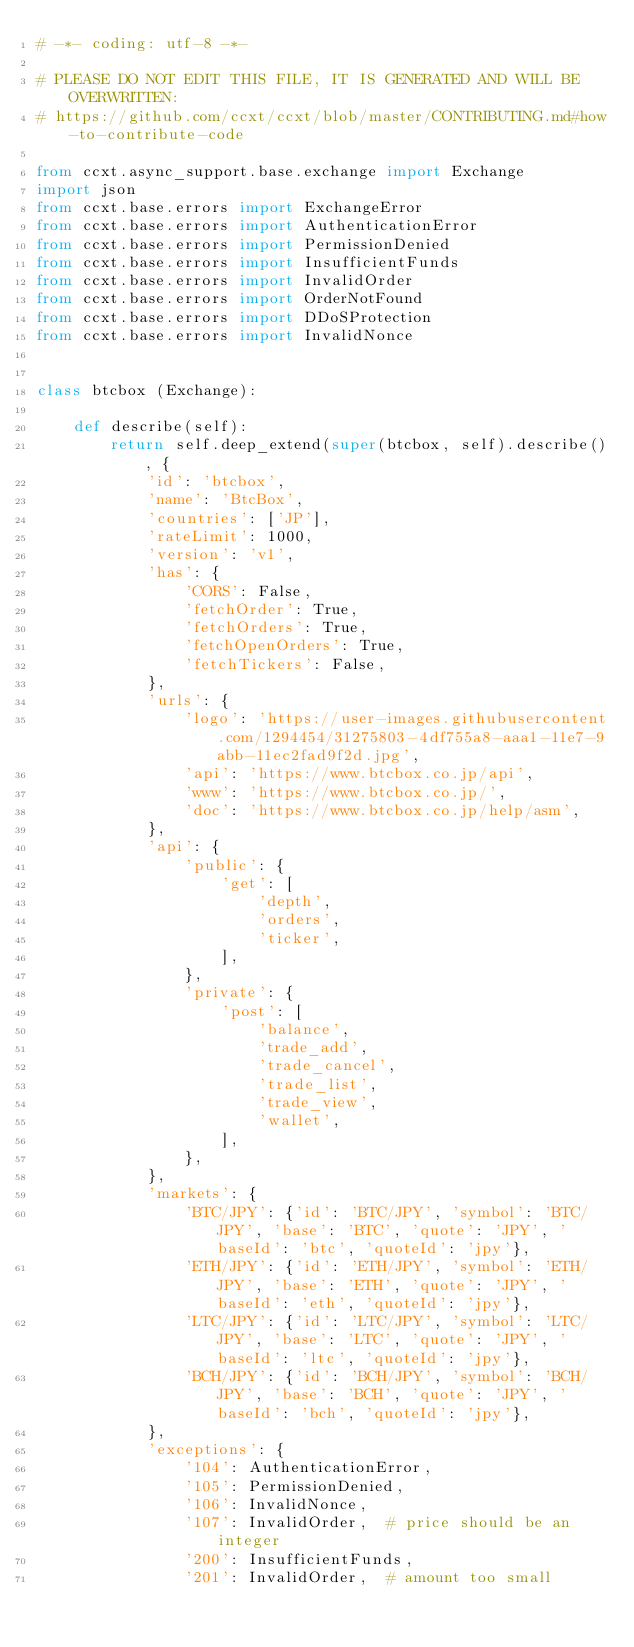<code> <loc_0><loc_0><loc_500><loc_500><_Python_># -*- coding: utf-8 -*-

# PLEASE DO NOT EDIT THIS FILE, IT IS GENERATED AND WILL BE OVERWRITTEN:
# https://github.com/ccxt/ccxt/blob/master/CONTRIBUTING.md#how-to-contribute-code

from ccxt.async_support.base.exchange import Exchange
import json
from ccxt.base.errors import ExchangeError
from ccxt.base.errors import AuthenticationError
from ccxt.base.errors import PermissionDenied
from ccxt.base.errors import InsufficientFunds
from ccxt.base.errors import InvalidOrder
from ccxt.base.errors import OrderNotFound
from ccxt.base.errors import DDoSProtection
from ccxt.base.errors import InvalidNonce


class btcbox (Exchange):

    def describe(self):
        return self.deep_extend(super(btcbox, self).describe(), {
            'id': 'btcbox',
            'name': 'BtcBox',
            'countries': ['JP'],
            'rateLimit': 1000,
            'version': 'v1',
            'has': {
                'CORS': False,
                'fetchOrder': True,
                'fetchOrders': True,
                'fetchOpenOrders': True,
                'fetchTickers': False,
            },
            'urls': {
                'logo': 'https://user-images.githubusercontent.com/1294454/31275803-4df755a8-aaa1-11e7-9abb-11ec2fad9f2d.jpg',
                'api': 'https://www.btcbox.co.jp/api',
                'www': 'https://www.btcbox.co.jp/',
                'doc': 'https://www.btcbox.co.jp/help/asm',
            },
            'api': {
                'public': {
                    'get': [
                        'depth',
                        'orders',
                        'ticker',
                    ],
                },
                'private': {
                    'post': [
                        'balance',
                        'trade_add',
                        'trade_cancel',
                        'trade_list',
                        'trade_view',
                        'wallet',
                    ],
                },
            },
            'markets': {
                'BTC/JPY': {'id': 'BTC/JPY', 'symbol': 'BTC/JPY', 'base': 'BTC', 'quote': 'JPY', 'baseId': 'btc', 'quoteId': 'jpy'},
                'ETH/JPY': {'id': 'ETH/JPY', 'symbol': 'ETH/JPY', 'base': 'ETH', 'quote': 'JPY', 'baseId': 'eth', 'quoteId': 'jpy'},
                'LTC/JPY': {'id': 'LTC/JPY', 'symbol': 'LTC/JPY', 'base': 'LTC', 'quote': 'JPY', 'baseId': 'ltc', 'quoteId': 'jpy'},
                'BCH/JPY': {'id': 'BCH/JPY', 'symbol': 'BCH/JPY', 'base': 'BCH', 'quote': 'JPY', 'baseId': 'bch', 'quoteId': 'jpy'},
            },
            'exceptions': {
                '104': AuthenticationError,
                '105': PermissionDenied,
                '106': InvalidNonce,
                '107': InvalidOrder,  # price should be an integer
                '200': InsufficientFunds,
                '201': InvalidOrder,  # amount too small</code> 